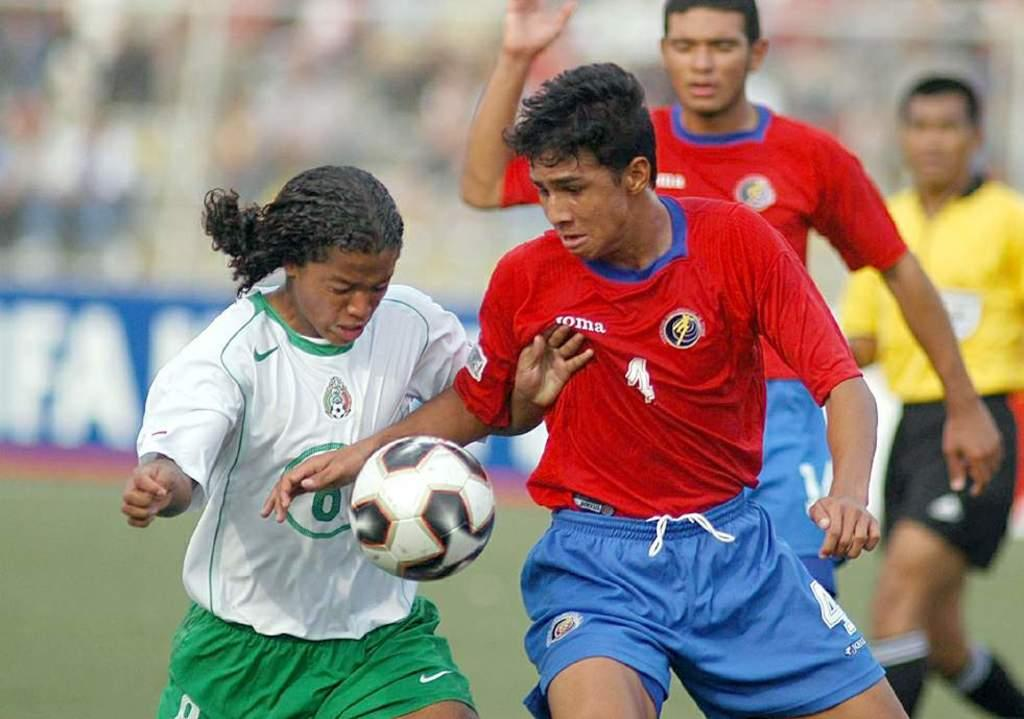<image>
Offer a succinct explanation of the picture presented. a soccer player with 4 on his shorts tries to get the ball from someone else 